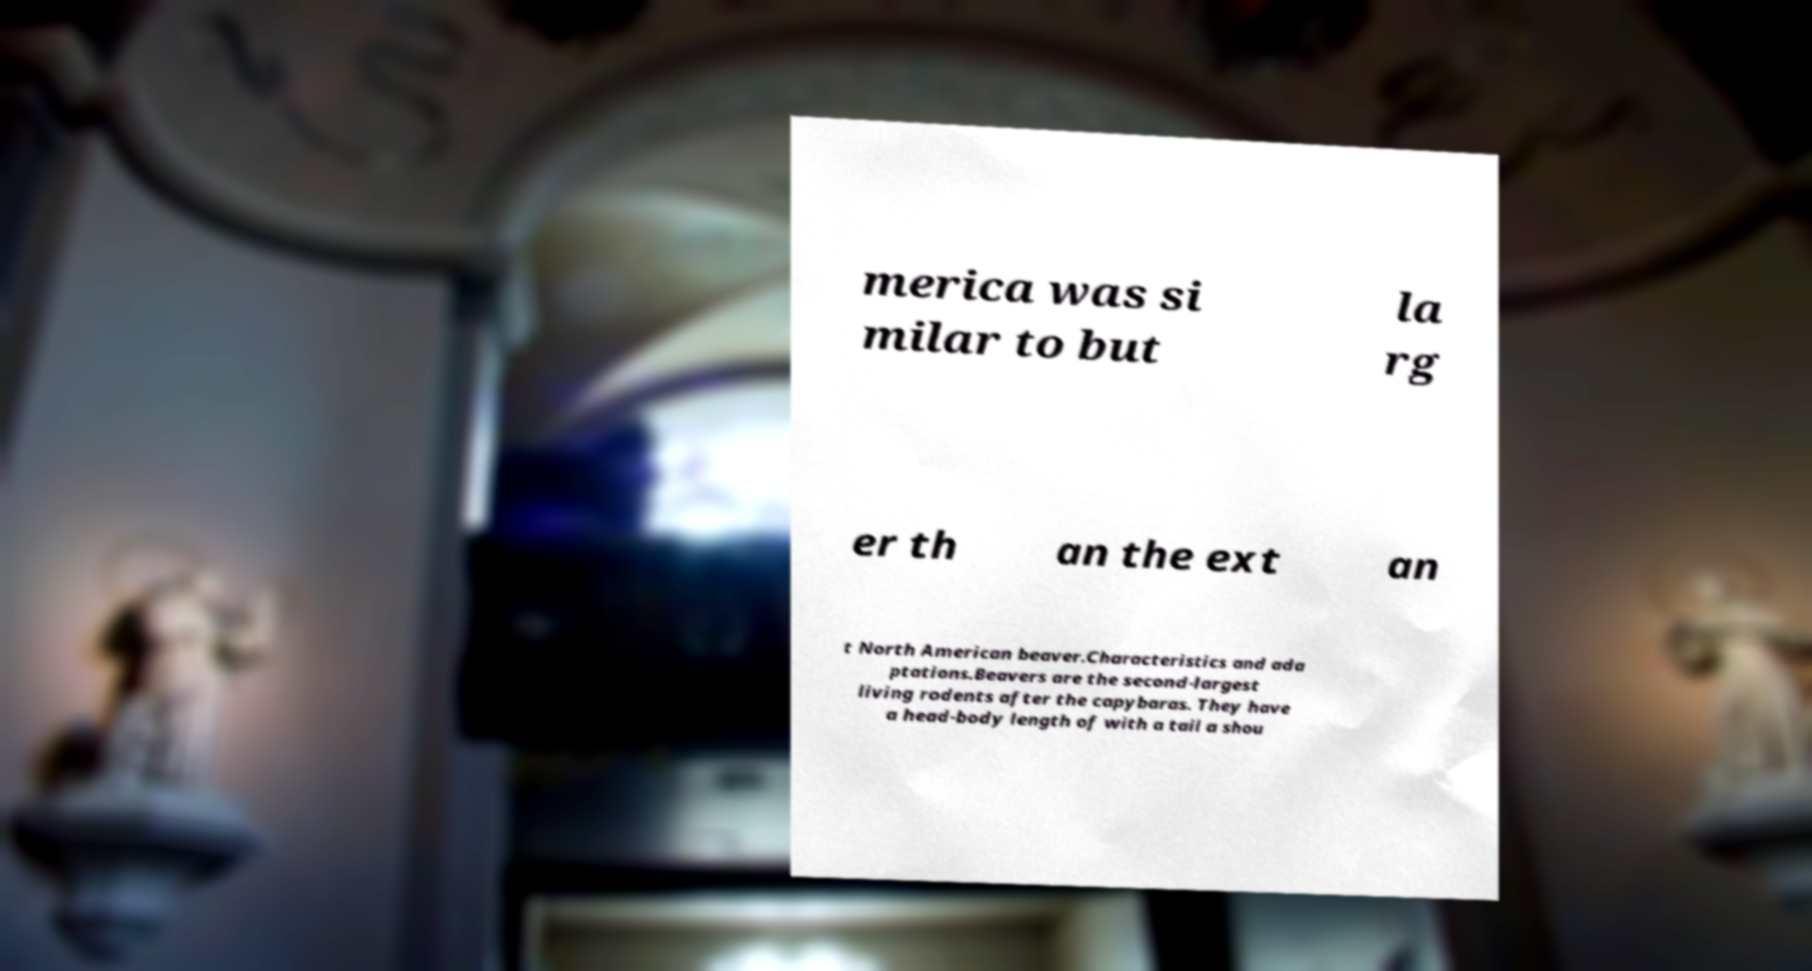What messages or text are displayed in this image? I need them in a readable, typed format. merica was si milar to but la rg er th an the ext an t North American beaver.Characteristics and ada ptations.Beavers are the second-largest living rodents after the capybaras. They have a head-body length of with a tail a shou 